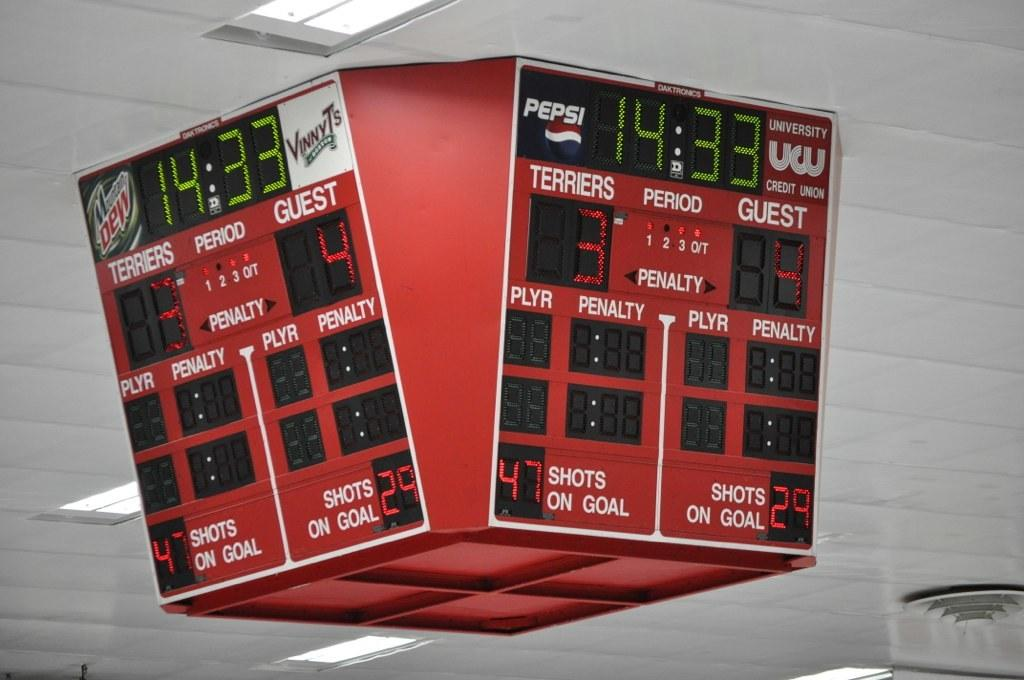<image>
Write a terse but informative summary of the picture. a red and white score board sponsored by pepsi 